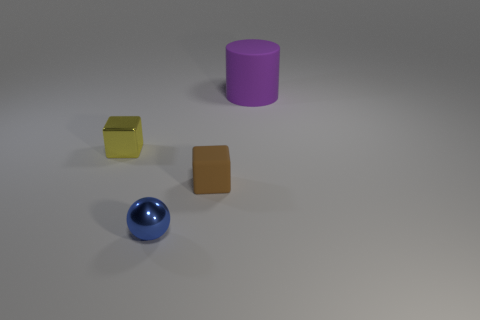How many objects are rubber objects that are on the right side of the small brown block or things on the left side of the big purple matte thing?
Give a very brief answer. 4. There is a yellow cube that is made of the same material as the blue ball; what is its size?
Keep it short and to the point. Small. Do the object behind the small shiny block and the tiny brown rubber thing have the same shape?
Make the answer very short. No. What number of gray objects are large rubber objects or shiny cubes?
Give a very brief answer. 0. How many other things are there of the same shape as the tiny rubber object?
Your answer should be very brief. 1. There is a object that is to the right of the tiny blue ball and in front of the large object; what is its shape?
Offer a very short reply. Cube. Are there any large purple cylinders in front of the blue metallic ball?
Your response must be concise. No. What is the size of the yellow shiny thing that is the same shape as the small brown matte thing?
Offer a very short reply. Small. Are there any other things that are the same size as the blue metallic ball?
Ensure brevity in your answer.  Yes. Does the big thing have the same shape as the tiny blue object?
Provide a succinct answer. No. 